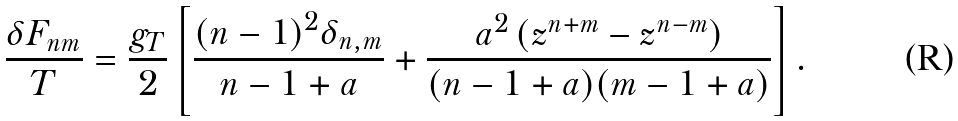<formula> <loc_0><loc_0><loc_500><loc_500>\frac { \delta F _ { n m } } { T } = \frac { g _ { T } } { 2 } \left [ \frac { ( n - 1 ) ^ { 2 } \delta _ { n , m } } { n - 1 + a } + \frac { a ^ { 2 } \left ( z ^ { n + m } - z ^ { n - m } \right ) } { ( n - 1 + a ) ( m - 1 + a ) } \right ] .</formula> 